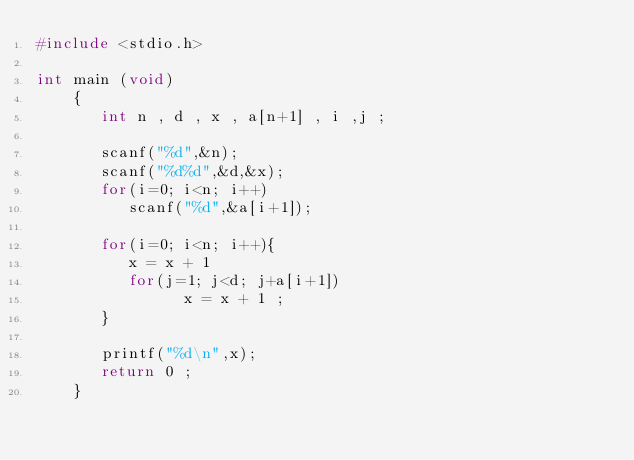Convert code to text. <code><loc_0><loc_0><loc_500><loc_500><_C_>#include <stdio.h>

int main (void)
    {
       int n , d , x , a[n+1] , i ,j ;
     
       scanf("%d",&n);
       scanf("%d%d",&d,&x);
       for(i=0; i<n; i++)
          scanf("%d",&a[i+1]);
     
       for(i=0; i<n; i++){
          x = x + 1
          for(j=1; j<d; j+a[i+1])
                x = x + 1 ;
       }
     
       printf("%d\n",x);     
       return 0 ;
    }</code> 